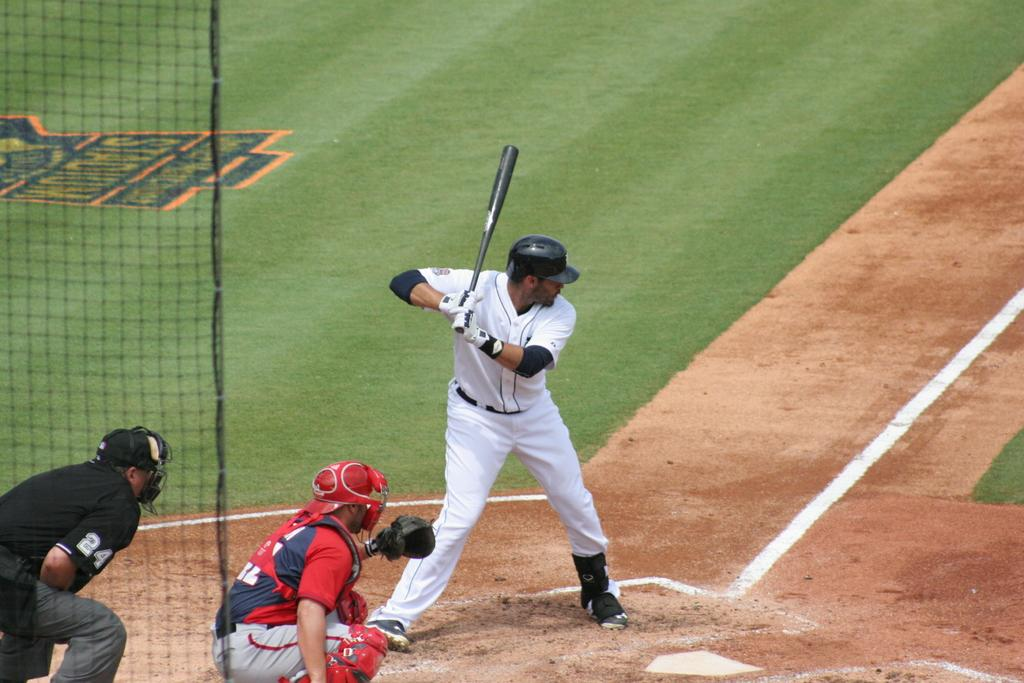<image>
Provide a brief description of the given image. Baseball player playing in front of a man wearing a shirt that has the number 24 on it. 